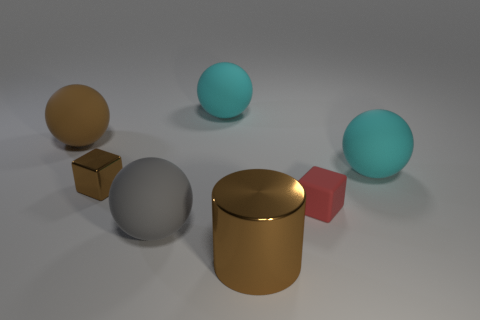Add 2 large cylinders. How many objects exist? 9 Subtract all cylinders. How many objects are left? 6 Subtract all large cyan matte cylinders. Subtract all cyan rubber objects. How many objects are left? 5 Add 7 tiny red matte blocks. How many tiny red matte blocks are left? 8 Add 4 cyan rubber things. How many cyan rubber things exist? 6 Subtract 0 purple blocks. How many objects are left? 7 